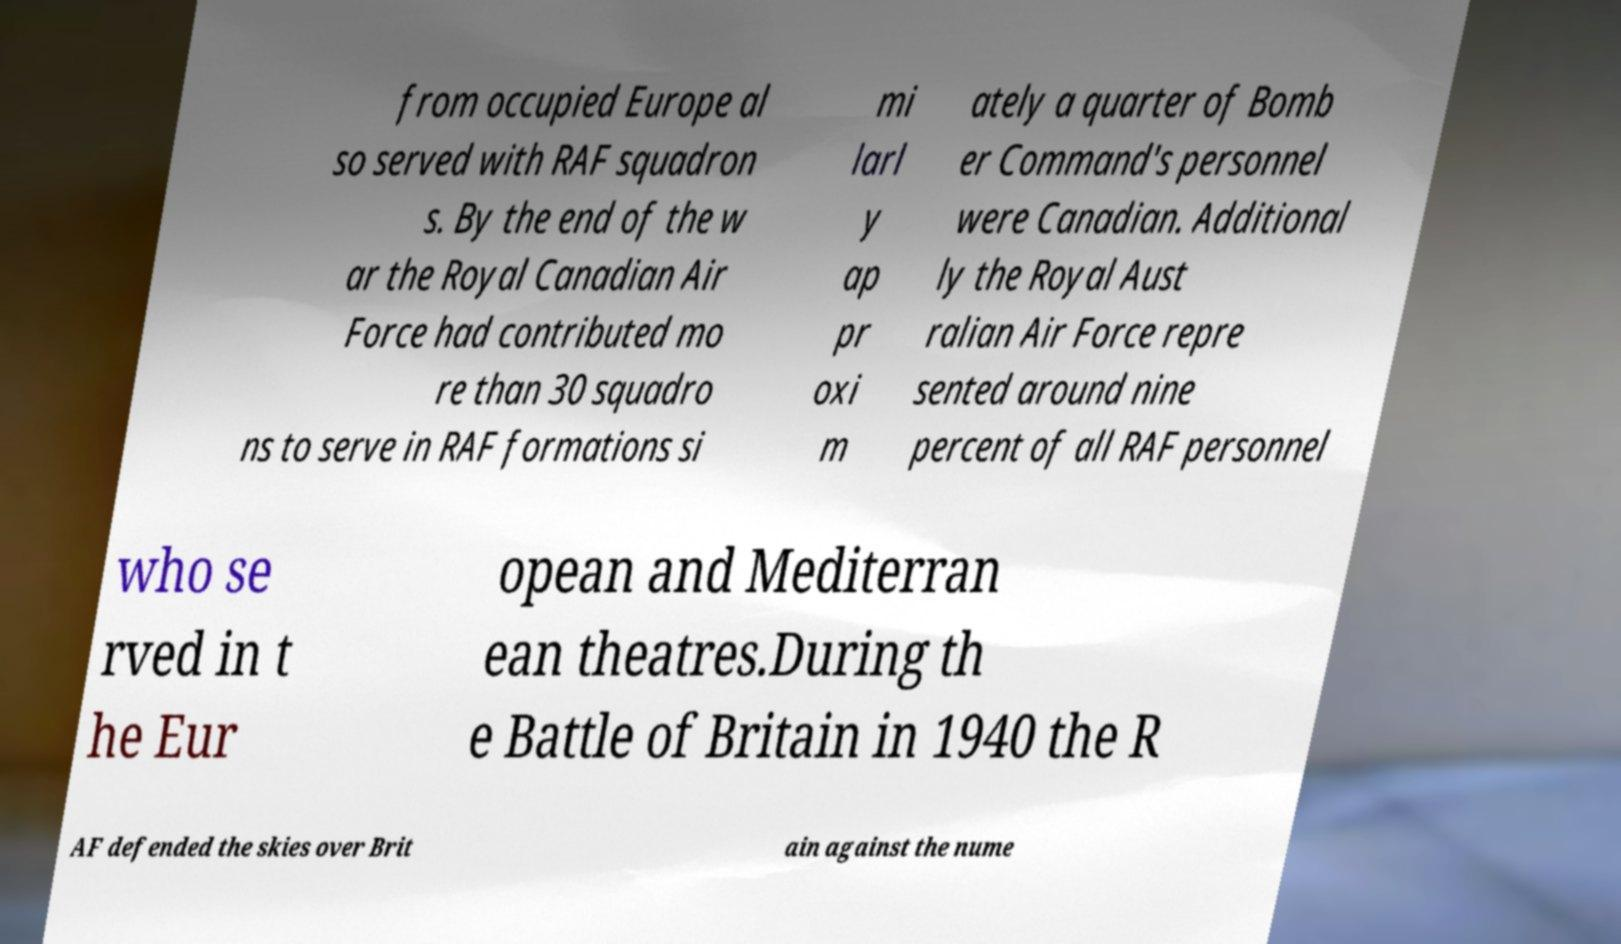I need the written content from this picture converted into text. Can you do that? from occupied Europe al so served with RAF squadron s. By the end of the w ar the Royal Canadian Air Force had contributed mo re than 30 squadro ns to serve in RAF formations si mi larl y ap pr oxi m ately a quarter of Bomb er Command's personnel were Canadian. Additional ly the Royal Aust ralian Air Force repre sented around nine percent of all RAF personnel who se rved in t he Eur opean and Mediterran ean theatres.During th e Battle of Britain in 1940 the R AF defended the skies over Brit ain against the nume 